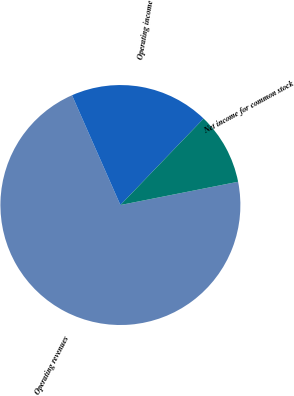Convert chart. <chart><loc_0><loc_0><loc_500><loc_500><pie_chart><fcel>Operating revenues<fcel>Operating income<fcel>Net income for common stock<nl><fcel>71.5%<fcel>18.8%<fcel>9.7%<nl></chart> 